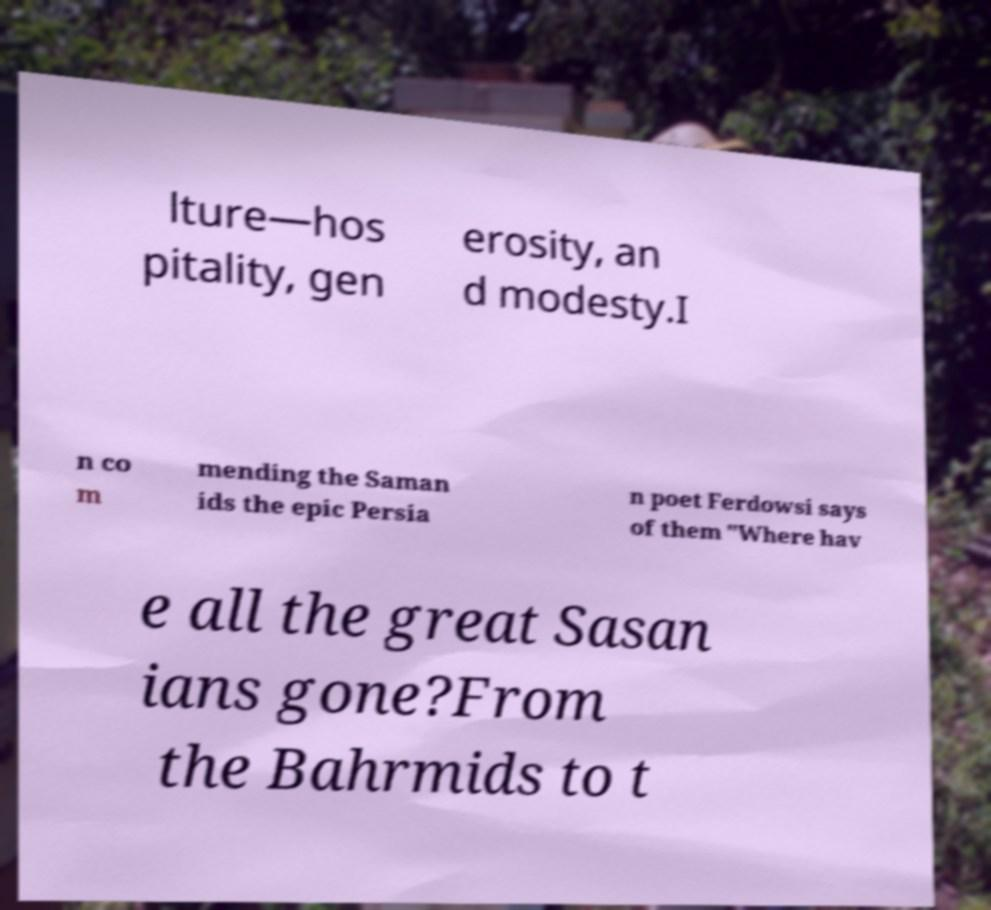For documentation purposes, I need the text within this image transcribed. Could you provide that? lture—hos pitality, gen erosity, an d modesty.I n co m mending the Saman ids the epic Persia n poet Ferdowsi says of them "Where hav e all the great Sasan ians gone?From the Bahrmids to t 